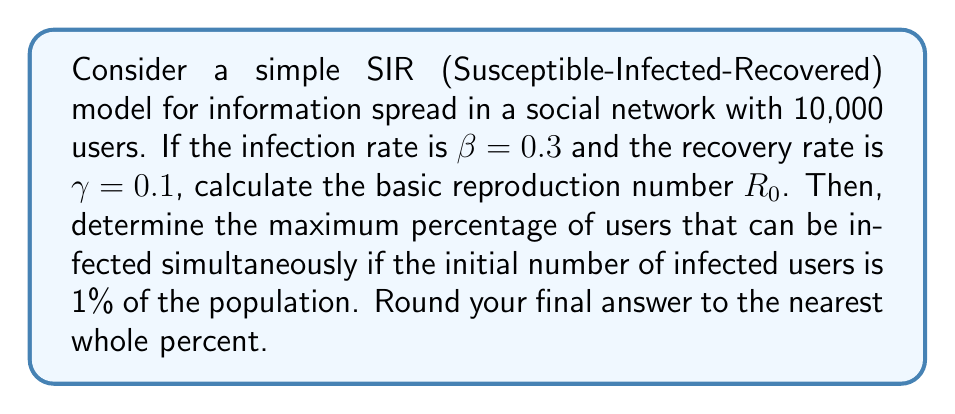Teach me how to tackle this problem. 1. Calculate the basic reproduction number $R_0$:
   $R_0 = \frac{\beta}{\gamma} = \frac{0.3}{0.1} = 3$

2. In the SIR model, the maximum percentage of infected users occurs when $\frac{dI}{dt} = 0$, which happens when:
   $S = \frac{N}{R_0} = \frac{10000}{3} \approx 3333.33$

3. The total number of users who will eventually be infected is:
   $N - S = 10000 - 3333.33 = 6666.67$

4. To find the maximum percentage of simultaneously infected users, we use the formula:
   $I_{max} = N(1 - \frac{1}{R_0} - \frac{\ln R_0}{R_0})$

5. Substitute the values:
   $I_{max} = 10000(1 - \frac{1}{3} - \frac{\ln 3}{3}) \approx 5108.56$

6. Convert to percentage:
   $\frac{5108.56}{10000} \times 100\% \approx 51.09\%$

7. Round to the nearest whole percent:
   $51\%$
Answer: 51% 